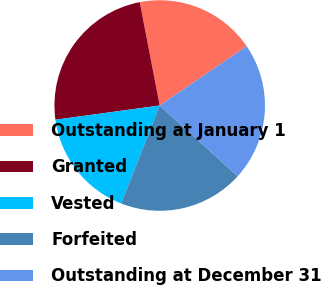<chart> <loc_0><loc_0><loc_500><loc_500><pie_chart><fcel>Outstanding at January 1<fcel>Granted<fcel>Vested<fcel>Forfeited<fcel>Outstanding at December 31<nl><fcel>18.51%<fcel>24.12%<fcel>16.89%<fcel>19.23%<fcel>21.25%<nl></chart> 